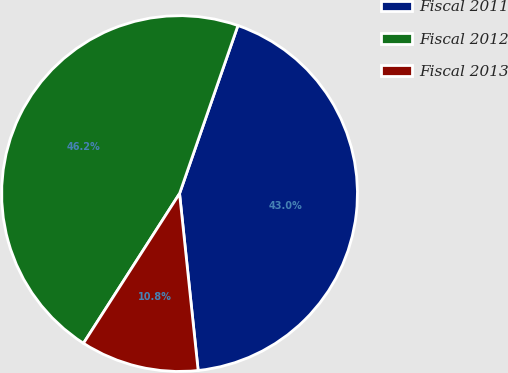<chart> <loc_0><loc_0><loc_500><loc_500><pie_chart><fcel>Fiscal 2011<fcel>Fiscal 2012<fcel>Fiscal 2013<nl><fcel>43.01%<fcel>46.24%<fcel>10.75%<nl></chart> 